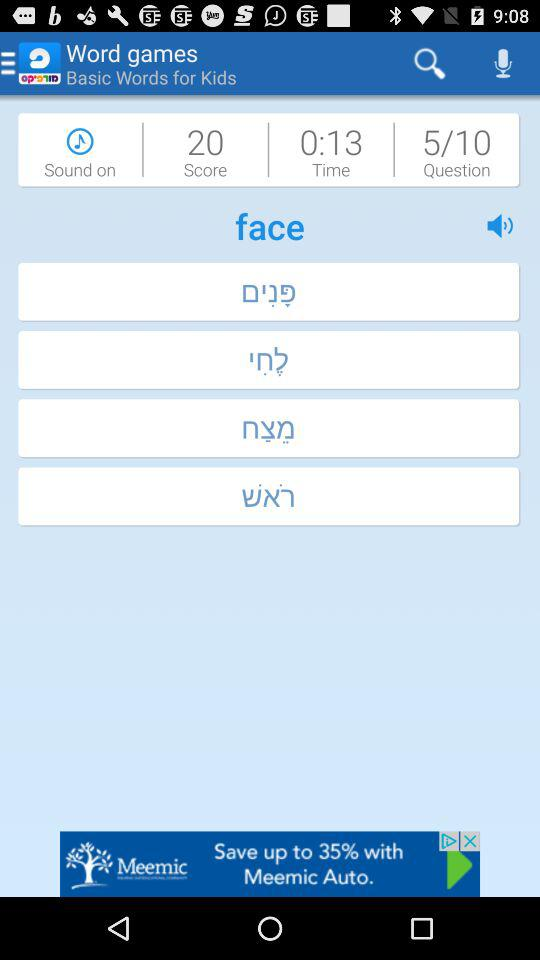What is the score of the game? The score is 20. 